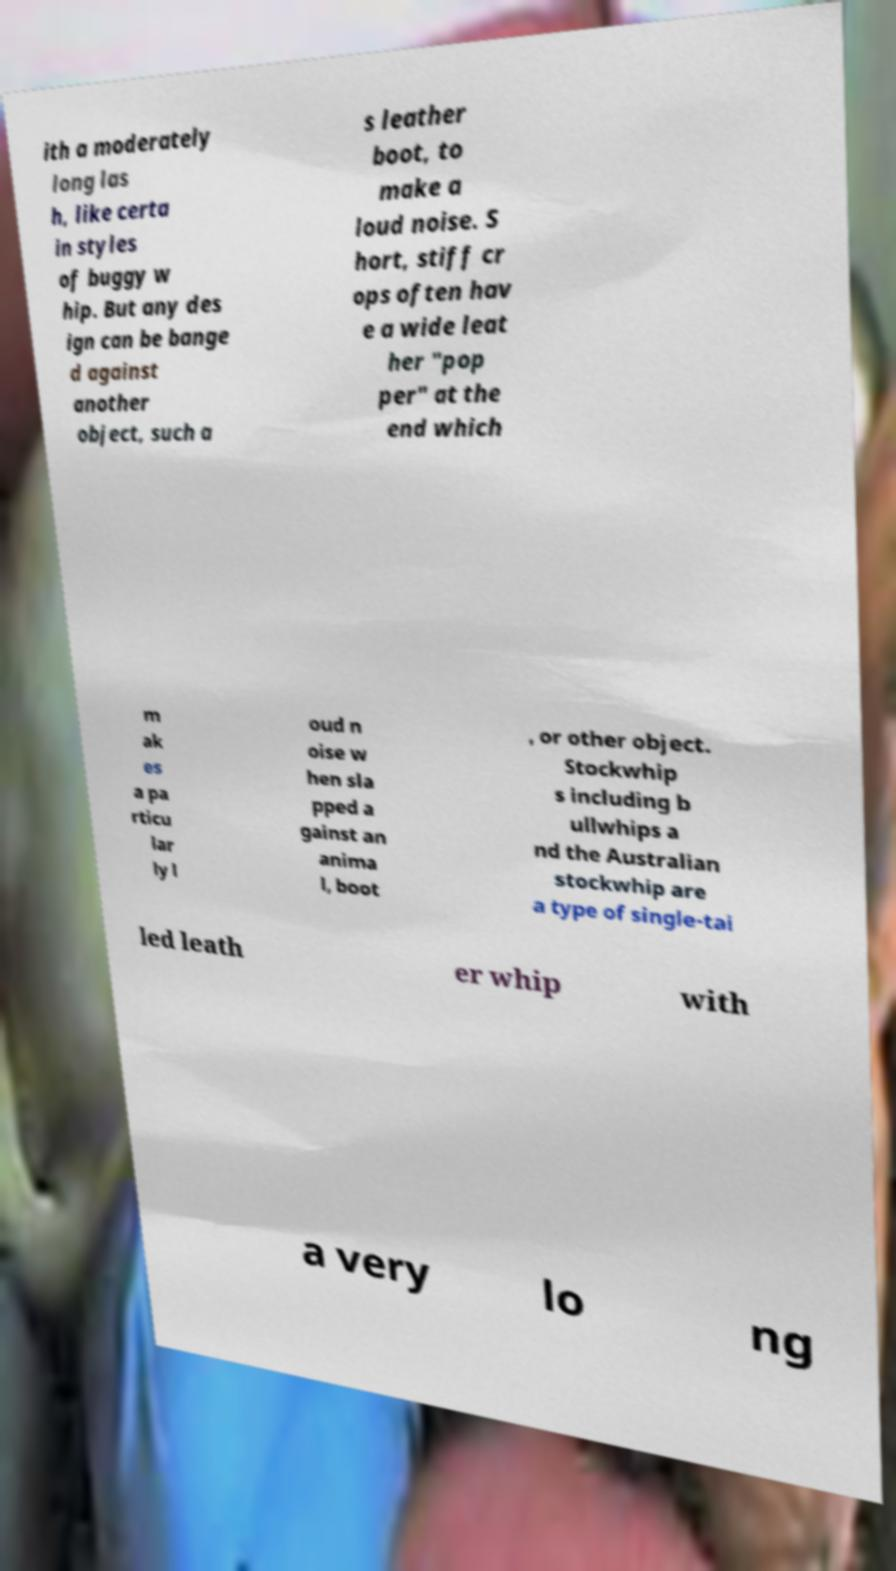Can you accurately transcribe the text from the provided image for me? ith a moderately long las h, like certa in styles of buggy w hip. But any des ign can be bange d against another object, such a s leather boot, to make a loud noise. S hort, stiff cr ops often hav e a wide leat her "pop per" at the end which m ak es a pa rticu lar ly l oud n oise w hen sla pped a gainst an anima l, boot , or other object. Stockwhip s including b ullwhips a nd the Australian stockwhip are a type of single-tai led leath er whip with a very lo ng 